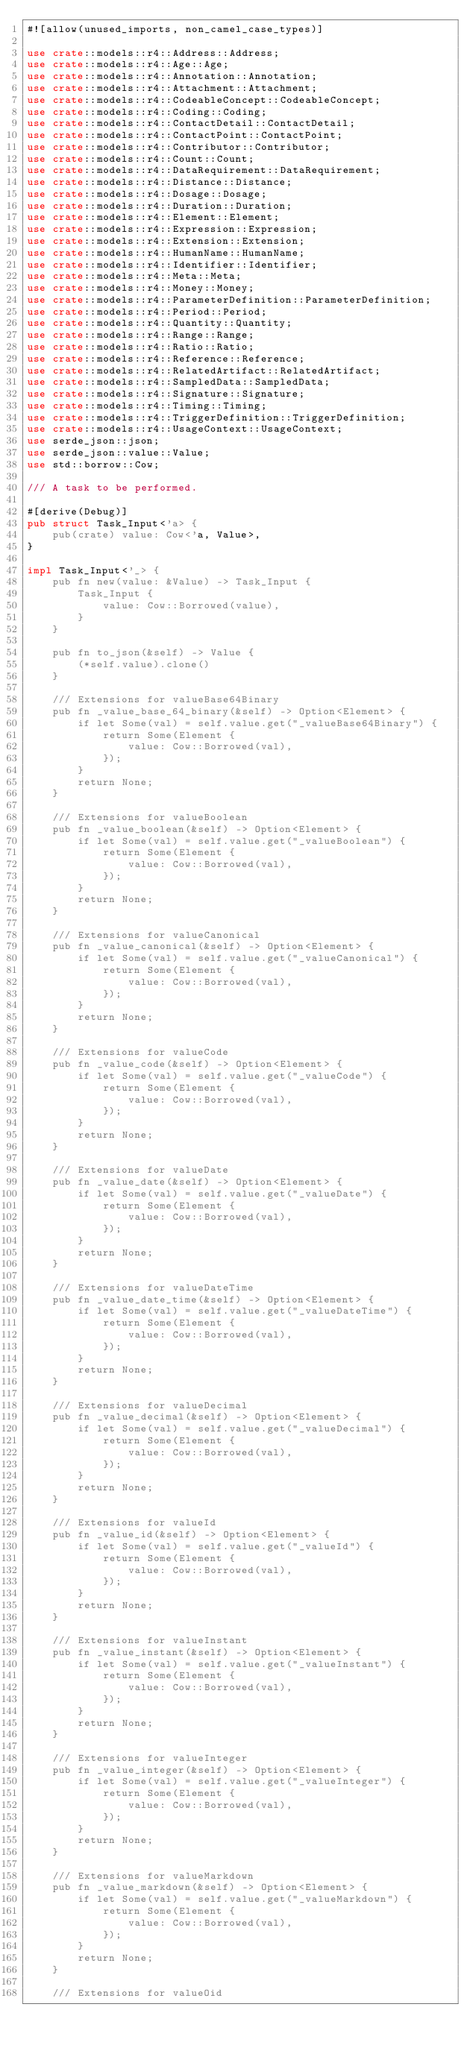Convert code to text. <code><loc_0><loc_0><loc_500><loc_500><_Rust_>#![allow(unused_imports, non_camel_case_types)]

use crate::models::r4::Address::Address;
use crate::models::r4::Age::Age;
use crate::models::r4::Annotation::Annotation;
use crate::models::r4::Attachment::Attachment;
use crate::models::r4::CodeableConcept::CodeableConcept;
use crate::models::r4::Coding::Coding;
use crate::models::r4::ContactDetail::ContactDetail;
use crate::models::r4::ContactPoint::ContactPoint;
use crate::models::r4::Contributor::Contributor;
use crate::models::r4::Count::Count;
use crate::models::r4::DataRequirement::DataRequirement;
use crate::models::r4::Distance::Distance;
use crate::models::r4::Dosage::Dosage;
use crate::models::r4::Duration::Duration;
use crate::models::r4::Element::Element;
use crate::models::r4::Expression::Expression;
use crate::models::r4::Extension::Extension;
use crate::models::r4::HumanName::HumanName;
use crate::models::r4::Identifier::Identifier;
use crate::models::r4::Meta::Meta;
use crate::models::r4::Money::Money;
use crate::models::r4::ParameterDefinition::ParameterDefinition;
use crate::models::r4::Period::Period;
use crate::models::r4::Quantity::Quantity;
use crate::models::r4::Range::Range;
use crate::models::r4::Ratio::Ratio;
use crate::models::r4::Reference::Reference;
use crate::models::r4::RelatedArtifact::RelatedArtifact;
use crate::models::r4::SampledData::SampledData;
use crate::models::r4::Signature::Signature;
use crate::models::r4::Timing::Timing;
use crate::models::r4::TriggerDefinition::TriggerDefinition;
use crate::models::r4::UsageContext::UsageContext;
use serde_json::json;
use serde_json::value::Value;
use std::borrow::Cow;

/// A task to be performed.

#[derive(Debug)]
pub struct Task_Input<'a> {
    pub(crate) value: Cow<'a, Value>,
}

impl Task_Input<'_> {
    pub fn new(value: &Value) -> Task_Input {
        Task_Input {
            value: Cow::Borrowed(value),
        }
    }

    pub fn to_json(&self) -> Value {
        (*self.value).clone()
    }

    /// Extensions for valueBase64Binary
    pub fn _value_base_64_binary(&self) -> Option<Element> {
        if let Some(val) = self.value.get("_valueBase64Binary") {
            return Some(Element {
                value: Cow::Borrowed(val),
            });
        }
        return None;
    }

    /// Extensions for valueBoolean
    pub fn _value_boolean(&self) -> Option<Element> {
        if let Some(val) = self.value.get("_valueBoolean") {
            return Some(Element {
                value: Cow::Borrowed(val),
            });
        }
        return None;
    }

    /// Extensions for valueCanonical
    pub fn _value_canonical(&self) -> Option<Element> {
        if let Some(val) = self.value.get("_valueCanonical") {
            return Some(Element {
                value: Cow::Borrowed(val),
            });
        }
        return None;
    }

    /// Extensions for valueCode
    pub fn _value_code(&self) -> Option<Element> {
        if let Some(val) = self.value.get("_valueCode") {
            return Some(Element {
                value: Cow::Borrowed(val),
            });
        }
        return None;
    }

    /// Extensions for valueDate
    pub fn _value_date(&self) -> Option<Element> {
        if let Some(val) = self.value.get("_valueDate") {
            return Some(Element {
                value: Cow::Borrowed(val),
            });
        }
        return None;
    }

    /// Extensions for valueDateTime
    pub fn _value_date_time(&self) -> Option<Element> {
        if let Some(val) = self.value.get("_valueDateTime") {
            return Some(Element {
                value: Cow::Borrowed(val),
            });
        }
        return None;
    }

    /// Extensions for valueDecimal
    pub fn _value_decimal(&self) -> Option<Element> {
        if let Some(val) = self.value.get("_valueDecimal") {
            return Some(Element {
                value: Cow::Borrowed(val),
            });
        }
        return None;
    }

    /// Extensions for valueId
    pub fn _value_id(&self) -> Option<Element> {
        if let Some(val) = self.value.get("_valueId") {
            return Some(Element {
                value: Cow::Borrowed(val),
            });
        }
        return None;
    }

    /// Extensions for valueInstant
    pub fn _value_instant(&self) -> Option<Element> {
        if let Some(val) = self.value.get("_valueInstant") {
            return Some(Element {
                value: Cow::Borrowed(val),
            });
        }
        return None;
    }

    /// Extensions for valueInteger
    pub fn _value_integer(&self) -> Option<Element> {
        if let Some(val) = self.value.get("_valueInteger") {
            return Some(Element {
                value: Cow::Borrowed(val),
            });
        }
        return None;
    }

    /// Extensions for valueMarkdown
    pub fn _value_markdown(&self) -> Option<Element> {
        if let Some(val) = self.value.get("_valueMarkdown") {
            return Some(Element {
                value: Cow::Borrowed(val),
            });
        }
        return None;
    }

    /// Extensions for valueOid</code> 